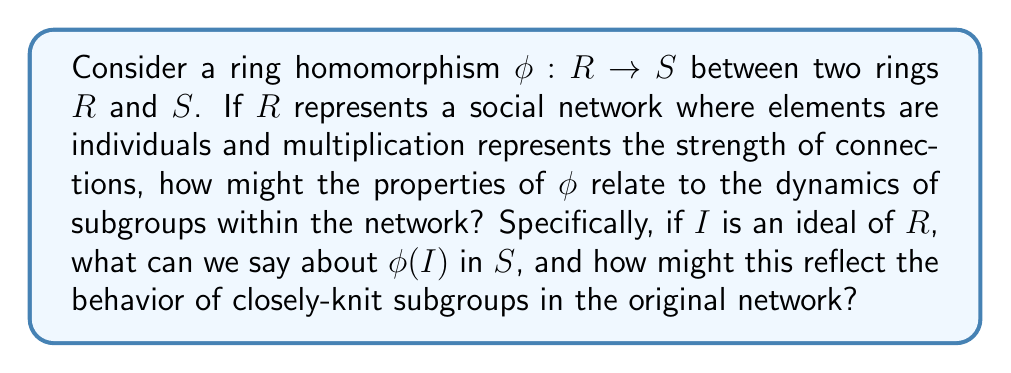Show me your answer to this math problem. To analyze this question, let's break it down step-by-step:

1) First, recall the properties of a ring homomorphism $\phi: R \to S$:
   a) $\phi(a + b) = \phi(a) + \phi(b)$ for all $a, b \in R$
   b) $\phi(ab) = \phi(a)\phi(b)$ for all $a, b \in R$
   c) $\phi(1_R) = 1_S$ if $R$ and $S$ have multiplicative identities

2) Now, let's consider an ideal $I$ of $R$. An ideal $I$ is a subring of $R$ with the additional property that for all $r \in R$ and $i \in I$, both $ri$ and $ir$ are in $I$.

3) In the context of our social network analogy:
   - Elements of $R$ represent individuals
   - Multiplication represents strength of connections
   - An ideal $I$ might represent a closely-knit subgroup where interactions with anyone in the main group always result in staying within the subgroup

4) Now, let's examine $\phi(I)$ in $S$:
   a) $\phi(I)$ is a subring of $S$, because $\phi$ preserves addition and multiplication
   b) However, $\phi(I)$ may not be an ideal in $S$

5) The fact that $\phi(I)$ may not be an ideal in $S$ is significant:
   - It means that the image of our closely-knit subgroup under $\phi$ might not maintain the same "closed" property in the new network
   - Some connections that were internal to the subgroup in $R$ might become external in $S$

6) This relates to group dynamics in the following way:
   - The homomorphism $\phi$ can be seen as a transformation of the social network
   - Closely-knit subgroups (represented by ideals) in the original network may not remain as tightly bound in the transformed network
   - This could represent, for example, how subgroups might change when the network undergoes a significant shift (e.g., a change in communication platform or social context)

7) However, we can say that $\phi(I)$ is always contained in an ideal of $S$, specifically the ideal generated by $\phi(I)$. This suggests that while the subgroup may not maintain its exact structure, it will still have some cohesion in the new network.
Answer: $\phi(I)$ is a subring of $S$ but not necessarily an ideal. This reflects how closely-knit subgroups in a social network may lose some of their cohesion when the network undergoes a transformation, but will still maintain some level of connection in the new structure. 